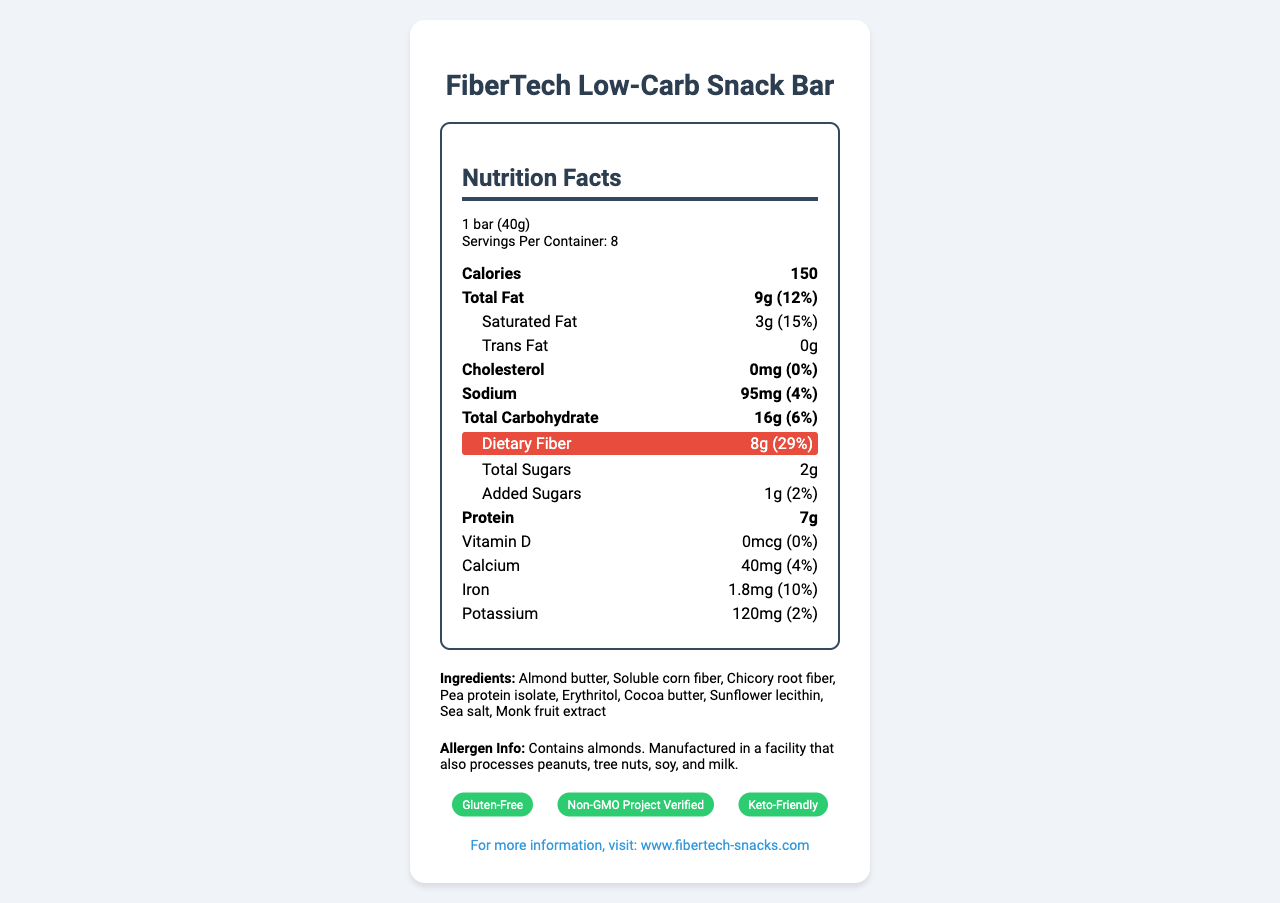what is the serving size of the snack bar? The serving size is mentioned in the document as "1 bar (40g)".
Answer: 1 bar (40g) how many calories are there per serving? The calories per serving are listed as 150.
Answer: 150 what is the dietary fiber content per serving? The dietary fiber content per serving is highlighted as 8g.
Answer: 8g what is the percentage of daily value for saturated fat? The percent daily value for saturated fat is 15%.
Answer: 15% how many grams of total sugars are in one bar? The total sugars in one bar are 2g.
Answer: 2g which ingredient is listed first? A. Pea protein isolate B. Almond butter C. Soluble corn fiber D. Erythritol Almond butter is the first ingredient listed.
Answer: B how much protein does one serving contain? One serving contains 7g of protein.
Answer: 7g how many servings are there per container? A. 5 B. 6 C. 7 D. 8 There are 8 servings per container.
Answer: D is the snack bar cholesterol-free? The cholesterol amount is listed as 0mg, meaning it is cholesterol-free.
Answer: Yes what certifications does the snack bar have? The snack bar has certifications for being Gluten-Free, Non-GMO Project Verified, and Keto-Friendly.
Answer: Gluten-Free, Non-GMO Project Verified, Keto-Friendly does the snack contain any peanuts? The document mentions it is manufactured in a facility that processes peanuts, but it doesn't state if it contains peanuts specifically.
Answer: Cannot be determined summarize the main features of the FiberTech Low-Carb Snack Bar. The document provides detailed nutritional information, ingredient lists, allergen info, certifications, and website reference for the FiberTech Low-Carb Snack Bar. The emphasis is on its high fiber content and low-carb nature, intended for consumers looking for healthy snack options within specific dietary requirements. The document also includes design tips for presenting such information effectively.
Answer: The FiberTech Low-Carb Snack Bar is a gluten-free, low-carb snack bar rich in fiber with 8g per serving. It contains 150 calories, 9g of total fat, and 7g of protein per serving. The snack bar is made with ingredients like almond butter and pea protein isolate. It has certifications for being Gluten-Free, Non-GMO Project Verified, and Keto-Friendly. Additionally, it is manufactured in a facility that processes common allergens. For more information, the website www.fibertech-snacks.com is provided. 